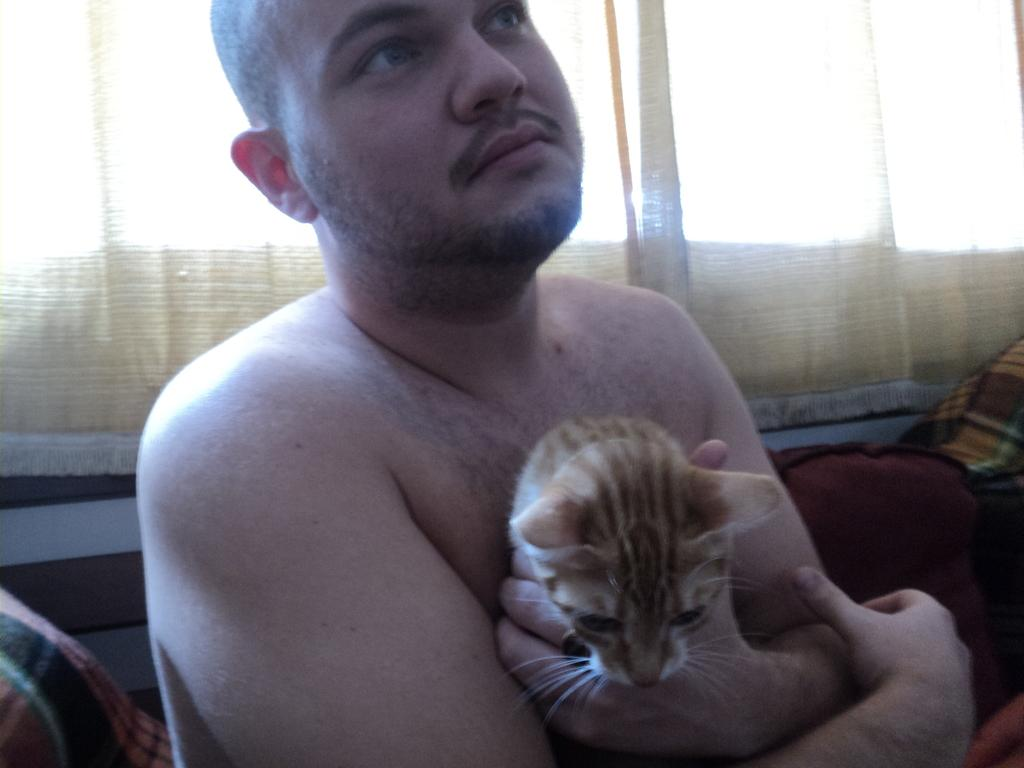Who is present in the image? There is a man in the image. What is the man holding in his hand? The man is holding a cat in his left hand. Where is the cat located in relation to the man? The cat is in the man's left hand. What riddle does the man whisper to the cat in the image? There is no indication in the image that the man is whispering a riddle to the cat. 